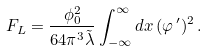<formula> <loc_0><loc_0><loc_500><loc_500>F _ { L } = \frac { \phi _ { 0 } ^ { 2 } } { 6 4 \pi ^ { 3 } \tilde { \lambda } } \int _ { - \infty } ^ { \infty } d x \, ( \varphi ^ { \, \prime } ) ^ { 2 } \, .</formula> 